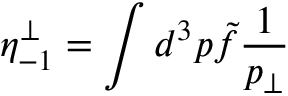<formula> <loc_0><loc_0><loc_500><loc_500>\eta _ { - 1 } ^ { \perp } = \int d ^ { 3 } p \tilde { f } { \frac { 1 } { p _ { \perp } } }</formula> 